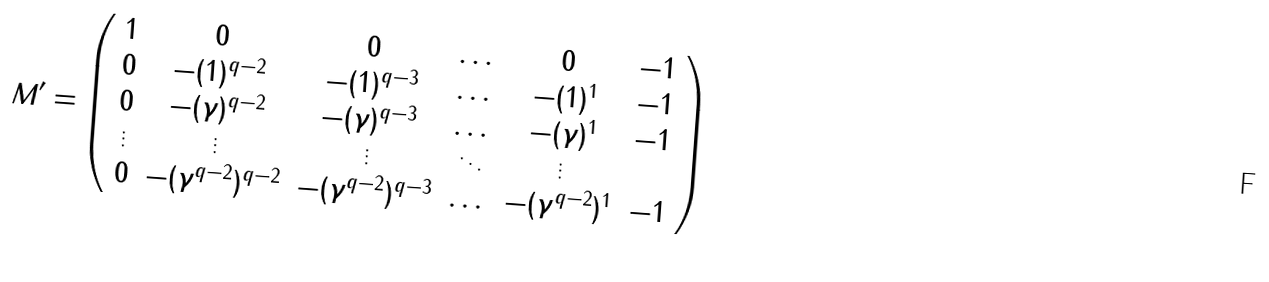<formula> <loc_0><loc_0><loc_500><loc_500>M ^ { \prime } = \left ( \begin{array} { c c c c c c } 1 & 0 & 0 & \dots & 0 & - 1 \\ 0 & - ( 1 { ) ^ { q - 2 } } & - ( 1 { ) ^ { q - 3 } } & \dots & - ( 1 { ) ^ { 1 } } & - 1 \\ 0 & - ( \gamma { ) ^ { q - 2 } } & - ( \gamma { ) ^ { q - 3 } } & \dots & - ( \gamma { ) ^ { 1 } } & - 1 \\ \vdots & \vdots & \vdots & \ddots & \vdots \\ 0 & - ( { \gamma ^ { q - 2 } } { ) ^ { q - 2 } } & - ( { \gamma ^ { q - 2 } } { ) ^ { q - 3 } } & \dots & - ( { \gamma ^ { q - 2 } } { ) ^ { 1 } } & - 1 \\ \end{array} \right )</formula> 